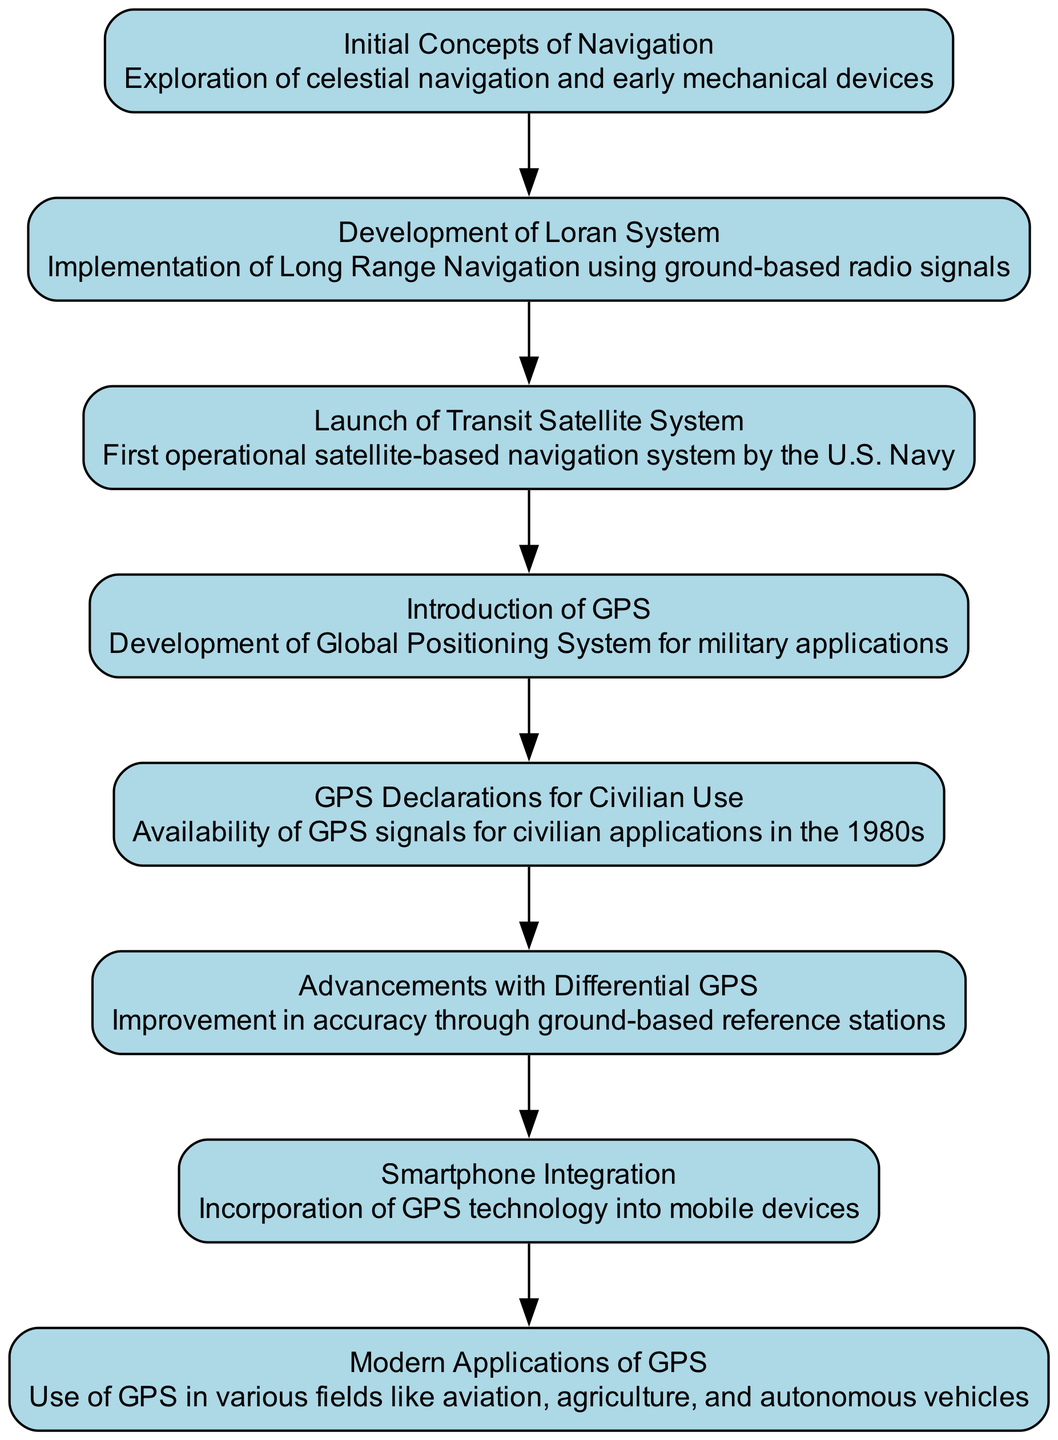What is the first event in the diagram? The first event listed in the sequence is "Initial Concepts of Navigation." This information is directly found at the beginning of the flow in the sequence diagram.
Answer: Initial Concepts of Navigation How many total events are shown in the diagram? By counting each unique event listed in the sequence, there are a total of 8 events. This involves simply enumerating each event from the first to the last.
Answer: 8 What event follows the development of the Loran System? The event that follows the "Development of Loran System" is "Launch of Transit Satellite System." This can be determined by observing the order of events in the diagram, where each event leads to the next in a sequential flow.
Answer: Launch of Transit Satellite System What type of navigation system was introduced after the introduction of GPS? After the "Introduction of GPS," the sequence mentions "GPS Declarations for Civilian Use." This requires tracking the flow from "Introduction of GPS" to the next event to identify the correct answer.
Answer: GPS Declarations for Civilian Use What technological advancement improved the accuracy of GPS? The advancement that improved GPS accuracy is "Differential GPS." This involves looking at the sequence of events to find the specific improvement noted after the introduction of GPS signals for civilian use.
Answer: Differential GPS Which event relates directly to modern uses of GPS technology? The event relating directly to modern uses of GPS technology is "Modern Applications of GPS." This is established by reviewing the latter part of the sequence that discusses contemporary applications.
Answer: Modern Applications of GPS What significant change occurred in the 1980s regarding GPS? In the 1980s, the significant change was the "GPS Declarations for Civilian Use." This conclusion comes from identifying the specific timeline in the sequence diagram where civilian access to GPS was introduced.
Answer: GPS Declarations for Civilian Use How did smartphones impact GPS technology? Smartphones integrated GPS technology, which is specified in the sequence as the "Smartphone Integration." This shows how the evolution of navigation technology has incorporated the widespread use of mobile devices.
Answer: Smartphone Integration 